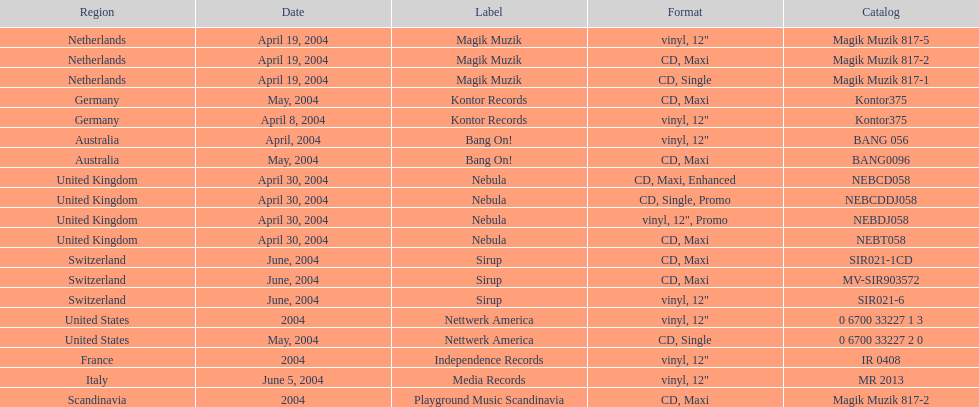How many catalogs were released? 19. 